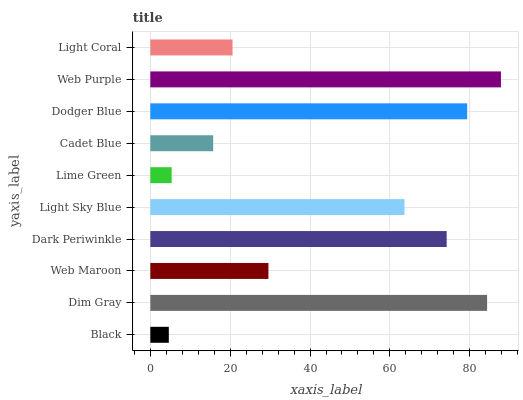Is Black the minimum?
Answer yes or no. Yes. Is Web Purple the maximum?
Answer yes or no. Yes. Is Dim Gray the minimum?
Answer yes or no. No. Is Dim Gray the maximum?
Answer yes or no. No. Is Dim Gray greater than Black?
Answer yes or no. Yes. Is Black less than Dim Gray?
Answer yes or no. Yes. Is Black greater than Dim Gray?
Answer yes or no. No. Is Dim Gray less than Black?
Answer yes or no. No. Is Light Sky Blue the high median?
Answer yes or no. Yes. Is Web Maroon the low median?
Answer yes or no. Yes. Is Dodger Blue the high median?
Answer yes or no. No. Is Dim Gray the low median?
Answer yes or no. No. 